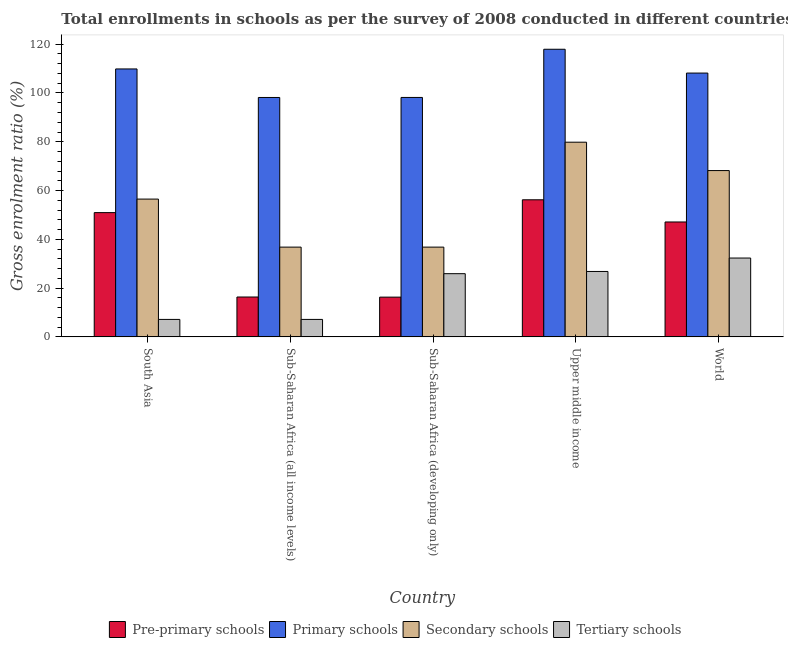Are the number of bars per tick equal to the number of legend labels?
Your answer should be very brief. Yes. How many bars are there on the 1st tick from the left?
Keep it short and to the point. 4. How many bars are there on the 3rd tick from the right?
Ensure brevity in your answer.  4. What is the label of the 5th group of bars from the left?
Ensure brevity in your answer.  World. What is the gross enrolment ratio in pre-primary schools in South Asia?
Your answer should be compact. 50.95. Across all countries, what is the maximum gross enrolment ratio in secondary schools?
Your answer should be very brief. 79.82. Across all countries, what is the minimum gross enrolment ratio in primary schools?
Your response must be concise. 98.16. In which country was the gross enrolment ratio in secondary schools maximum?
Offer a very short reply. Upper middle income. In which country was the gross enrolment ratio in primary schools minimum?
Your answer should be compact. Sub-Saharan Africa (all income levels). What is the total gross enrolment ratio in tertiary schools in the graph?
Offer a very short reply. 99.37. What is the difference between the gross enrolment ratio in secondary schools in Sub-Saharan Africa (developing only) and that in Upper middle income?
Give a very brief answer. -43.02. What is the difference between the gross enrolment ratio in tertiary schools in Upper middle income and the gross enrolment ratio in pre-primary schools in South Asia?
Give a very brief answer. -24.13. What is the average gross enrolment ratio in tertiary schools per country?
Give a very brief answer. 19.87. What is the difference between the gross enrolment ratio in primary schools and gross enrolment ratio in tertiary schools in Sub-Saharan Africa (developing only)?
Give a very brief answer. 72.26. In how many countries, is the gross enrolment ratio in pre-primary schools greater than 12 %?
Offer a very short reply. 5. What is the ratio of the gross enrolment ratio in tertiary schools in South Asia to that in World?
Keep it short and to the point. 0.22. Is the gross enrolment ratio in secondary schools in Sub-Saharan Africa (developing only) less than that in Upper middle income?
Your response must be concise. Yes. What is the difference between the highest and the second highest gross enrolment ratio in tertiary schools?
Provide a short and direct response. 5.5. What is the difference between the highest and the lowest gross enrolment ratio in primary schools?
Provide a succinct answer. 19.77. In how many countries, is the gross enrolment ratio in pre-primary schools greater than the average gross enrolment ratio in pre-primary schools taken over all countries?
Your answer should be very brief. 3. Is the sum of the gross enrolment ratio in tertiary schools in Sub-Saharan Africa (developing only) and World greater than the maximum gross enrolment ratio in primary schools across all countries?
Provide a short and direct response. No. Is it the case that in every country, the sum of the gross enrolment ratio in tertiary schools and gross enrolment ratio in primary schools is greater than the sum of gross enrolment ratio in secondary schools and gross enrolment ratio in pre-primary schools?
Offer a very short reply. Yes. What does the 3rd bar from the left in South Asia represents?
Provide a succinct answer. Secondary schools. What does the 3rd bar from the right in Sub-Saharan Africa (developing only) represents?
Offer a terse response. Primary schools. How many bars are there?
Provide a succinct answer. 20. Are the values on the major ticks of Y-axis written in scientific E-notation?
Offer a very short reply. No. Where does the legend appear in the graph?
Your answer should be very brief. Bottom center. How many legend labels are there?
Offer a terse response. 4. How are the legend labels stacked?
Offer a terse response. Horizontal. What is the title of the graph?
Offer a terse response. Total enrollments in schools as per the survey of 2008 conducted in different countries. Does "Other Minerals" appear as one of the legend labels in the graph?
Your response must be concise. No. What is the label or title of the Y-axis?
Keep it short and to the point. Gross enrolment ratio (%). What is the Gross enrolment ratio (%) in Pre-primary schools in South Asia?
Ensure brevity in your answer.  50.95. What is the Gross enrolment ratio (%) in Primary schools in South Asia?
Your answer should be very brief. 109.86. What is the Gross enrolment ratio (%) in Secondary schools in South Asia?
Your answer should be compact. 56.5. What is the Gross enrolment ratio (%) of Tertiary schools in South Asia?
Offer a terse response. 7.16. What is the Gross enrolment ratio (%) in Pre-primary schools in Sub-Saharan Africa (all income levels)?
Provide a short and direct response. 16.34. What is the Gross enrolment ratio (%) in Primary schools in Sub-Saharan Africa (all income levels)?
Make the answer very short. 98.16. What is the Gross enrolment ratio (%) in Secondary schools in Sub-Saharan Africa (all income levels)?
Keep it short and to the point. 36.8. What is the Gross enrolment ratio (%) in Tertiary schools in Sub-Saharan Africa (all income levels)?
Your answer should be very brief. 7.16. What is the Gross enrolment ratio (%) of Pre-primary schools in Sub-Saharan Africa (developing only)?
Your response must be concise. 16.3. What is the Gross enrolment ratio (%) of Primary schools in Sub-Saharan Africa (developing only)?
Provide a succinct answer. 98.17. What is the Gross enrolment ratio (%) in Secondary schools in Sub-Saharan Africa (developing only)?
Ensure brevity in your answer.  36.8. What is the Gross enrolment ratio (%) in Tertiary schools in Sub-Saharan Africa (developing only)?
Your response must be concise. 25.91. What is the Gross enrolment ratio (%) of Pre-primary schools in Upper middle income?
Provide a short and direct response. 56.21. What is the Gross enrolment ratio (%) of Primary schools in Upper middle income?
Make the answer very short. 117.93. What is the Gross enrolment ratio (%) in Secondary schools in Upper middle income?
Offer a very short reply. 79.82. What is the Gross enrolment ratio (%) in Tertiary schools in Upper middle income?
Keep it short and to the point. 26.82. What is the Gross enrolment ratio (%) in Pre-primary schools in World?
Offer a terse response. 47.11. What is the Gross enrolment ratio (%) in Primary schools in World?
Make the answer very short. 108.17. What is the Gross enrolment ratio (%) in Secondary schools in World?
Make the answer very short. 68.19. What is the Gross enrolment ratio (%) in Tertiary schools in World?
Your answer should be very brief. 32.32. Across all countries, what is the maximum Gross enrolment ratio (%) of Pre-primary schools?
Your answer should be compact. 56.21. Across all countries, what is the maximum Gross enrolment ratio (%) of Primary schools?
Your answer should be very brief. 117.93. Across all countries, what is the maximum Gross enrolment ratio (%) in Secondary schools?
Provide a short and direct response. 79.82. Across all countries, what is the maximum Gross enrolment ratio (%) in Tertiary schools?
Provide a short and direct response. 32.32. Across all countries, what is the minimum Gross enrolment ratio (%) in Pre-primary schools?
Provide a succinct answer. 16.3. Across all countries, what is the minimum Gross enrolment ratio (%) in Primary schools?
Your response must be concise. 98.16. Across all countries, what is the minimum Gross enrolment ratio (%) in Secondary schools?
Ensure brevity in your answer.  36.8. Across all countries, what is the minimum Gross enrolment ratio (%) in Tertiary schools?
Your answer should be compact. 7.16. What is the total Gross enrolment ratio (%) of Pre-primary schools in the graph?
Your answer should be very brief. 186.91. What is the total Gross enrolment ratio (%) of Primary schools in the graph?
Provide a succinct answer. 532.28. What is the total Gross enrolment ratio (%) of Secondary schools in the graph?
Give a very brief answer. 278.1. What is the total Gross enrolment ratio (%) of Tertiary schools in the graph?
Ensure brevity in your answer.  99.37. What is the difference between the Gross enrolment ratio (%) in Pre-primary schools in South Asia and that in Sub-Saharan Africa (all income levels)?
Your response must be concise. 34.6. What is the difference between the Gross enrolment ratio (%) in Primary schools in South Asia and that in Sub-Saharan Africa (all income levels)?
Provide a succinct answer. 11.7. What is the difference between the Gross enrolment ratio (%) in Secondary schools in South Asia and that in Sub-Saharan Africa (all income levels)?
Provide a succinct answer. 19.7. What is the difference between the Gross enrolment ratio (%) in Tertiary schools in South Asia and that in Sub-Saharan Africa (all income levels)?
Make the answer very short. -0. What is the difference between the Gross enrolment ratio (%) of Pre-primary schools in South Asia and that in Sub-Saharan Africa (developing only)?
Provide a short and direct response. 34.65. What is the difference between the Gross enrolment ratio (%) of Primary schools in South Asia and that in Sub-Saharan Africa (developing only)?
Offer a terse response. 11.69. What is the difference between the Gross enrolment ratio (%) of Secondary schools in South Asia and that in Sub-Saharan Africa (developing only)?
Give a very brief answer. 19.69. What is the difference between the Gross enrolment ratio (%) of Tertiary schools in South Asia and that in Sub-Saharan Africa (developing only)?
Give a very brief answer. -18.75. What is the difference between the Gross enrolment ratio (%) in Pre-primary schools in South Asia and that in Upper middle income?
Provide a succinct answer. -5.26. What is the difference between the Gross enrolment ratio (%) of Primary schools in South Asia and that in Upper middle income?
Your answer should be very brief. -8.07. What is the difference between the Gross enrolment ratio (%) of Secondary schools in South Asia and that in Upper middle income?
Make the answer very short. -23.32. What is the difference between the Gross enrolment ratio (%) in Tertiary schools in South Asia and that in Upper middle income?
Offer a very short reply. -19.66. What is the difference between the Gross enrolment ratio (%) of Pre-primary schools in South Asia and that in World?
Offer a very short reply. 3.83. What is the difference between the Gross enrolment ratio (%) in Primary schools in South Asia and that in World?
Make the answer very short. 1.69. What is the difference between the Gross enrolment ratio (%) of Secondary schools in South Asia and that in World?
Your answer should be very brief. -11.69. What is the difference between the Gross enrolment ratio (%) in Tertiary schools in South Asia and that in World?
Offer a very short reply. -25.16. What is the difference between the Gross enrolment ratio (%) in Pre-primary schools in Sub-Saharan Africa (all income levels) and that in Sub-Saharan Africa (developing only)?
Offer a very short reply. 0.05. What is the difference between the Gross enrolment ratio (%) of Primary schools in Sub-Saharan Africa (all income levels) and that in Sub-Saharan Africa (developing only)?
Provide a succinct answer. -0.01. What is the difference between the Gross enrolment ratio (%) of Secondary schools in Sub-Saharan Africa (all income levels) and that in Sub-Saharan Africa (developing only)?
Provide a short and direct response. -0. What is the difference between the Gross enrolment ratio (%) of Tertiary schools in Sub-Saharan Africa (all income levels) and that in Sub-Saharan Africa (developing only)?
Ensure brevity in your answer.  -18.75. What is the difference between the Gross enrolment ratio (%) in Pre-primary schools in Sub-Saharan Africa (all income levels) and that in Upper middle income?
Ensure brevity in your answer.  -39.86. What is the difference between the Gross enrolment ratio (%) in Primary schools in Sub-Saharan Africa (all income levels) and that in Upper middle income?
Your answer should be compact. -19.77. What is the difference between the Gross enrolment ratio (%) of Secondary schools in Sub-Saharan Africa (all income levels) and that in Upper middle income?
Offer a very short reply. -43.02. What is the difference between the Gross enrolment ratio (%) in Tertiary schools in Sub-Saharan Africa (all income levels) and that in Upper middle income?
Make the answer very short. -19.66. What is the difference between the Gross enrolment ratio (%) of Pre-primary schools in Sub-Saharan Africa (all income levels) and that in World?
Keep it short and to the point. -30.77. What is the difference between the Gross enrolment ratio (%) in Primary schools in Sub-Saharan Africa (all income levels) and that in World?
Offer a very short reply. -10.01. What is the difference between the Gross enrolment ratio (%) of Secondary schools in Sub-Saharan Africa (all income levels) and that in World?
Provide a succinct answer. -31.39. What is the difference between the Gross enrolment ratio (%) of Tertiary schools in Sub-Saharan Africa (all income levels) and that in World?
Provide a short and direct response. -25.16. What is the difference between the Gross enrolment ratio (%) in Pre-primary schools in Sub-Saharan Africa (developing only) and that in Upper middle income?
Your answer should be very brief. -39.91. What is the difference between the Gross enrolment ratio (%) of Primary schools in Sub-Saharan Africa (developing only) and that in Upper middle income?
Make the answer very short. -19.76. What is the difference between the Gross enrolment ratio (%) in Secondary schools in Sub-Saharan Africa (developing only) and that in Upper middle income?
Make the answer very short. -43.02. What is the difference between the Gross enrolment ratio (%) in Tertiary schools in Sub-Saharan Africa (developing only) and that in Upper middle income?
Ensure brevity in your answer.  -0.91. What is the difference between the Gross enrolment ratio (%) in Pre-primary schools in Sub-Saharan Africa (developing only) and that in World?
Your answer should be compact. -30.82. What is the difference between the Gross enrolment ratio (%) of Primary schools in Sub-Saharan Africa (developing only) and that in World?
Offer a very short reply. -10. What is the difference between the Gross enrolment ratio (%) in Secondary schools in Sub-Saharan Africa (developing only) and that in World?
Offer a terse response. -31.39. What is the difference between the Gross enrolment ratio (%) of Tertiary schools in Sub-Saharan Africa (developing only) and that in World?
Your answer should be compact. -6.41. What is the difference between the Gross enrolment ratio (%) of Pre-primary schools in Upper middle income and that in World?
Offer a very short reply. 9.1. What is the difference between the Gross enrolment ratio (%) in Primary schools in Upper middle income and that in World?
Make the answer very short. 9.76. What is the difference between the Gross enrolment ratio (%) of Secondary schools in Upper middle income and that in World?
Provide a short and direct response. 11.63. What is the difference between the Gross enrolment ratio (%) of Tertiary schools in Upper middle income and that in World?
Your answer should be compact. -5.5. What is the difference between the Gross enrolment ratio (%) of Pre-primary schools in South Asia and the Gross enrolment ratio (%) of Primary schools in Sub-Saharan Africa (all income levels)?
Your answer should be very brief. -47.21. What is the difference between the Gross enrolment ratio (%) of Pre-primary schools in South Asia and the Gross enrolment ratio (%) of Secondary schools in Sub-Saharan Africa (all income levels)?
Your response must be concise. 14.15. What is the difference between the Gross enrolment ratio (%) of Pre-primary schools in South Asia and the Gross enrolment ratio (%) of Tertiary schools in Sub-Saharan Africa (all income levels)?
Provide a succinct answer. 43.79. What is the difference between the Gross enrolment ratio (%) in Primary schools in South Asia and the Gross enrolment ratio (%) in Secondary schools in Sub-Saharan Africa (all income levels)?
Provide a short and direct response. 73.06. What is the difference between the Gross enrolment ratio (%) of Primary schools in South Asia and the Gross enrolment ratio (%) of Tertiary schools in Sub-Saharan Africa (all income levels)?
Give a very brief answer. 102.7. What is the difference between the Gross enrolment ratio (%) in Secondary schools in South Asia and the Gross enrolment ratio (%) in Tertiary schools in Sub-Saharan Africa (all income levels)?
Offer a very short reply. 49.33. What is the difference between the Gross enrolment ratio (%) in Pre-primary schools in South Asia and the Gross enrolment ratio (%) in Primary schools in Sub-Saharan Africa (developing only)?
Offer a very short reply. -47.22. What is the difference between the Gross enrolment ratio (%) of Pre-primary schools in South Asia and the Gross enrolment ratio (%) of Secondary schools in Sub-Saharan Africa (developing only)?
Provide a short and direct response. 14.14. What is the difference between the Gross enrolment ratio (%) of Pre-primary schools in South Asia and the Gross enrolment ratio (%) of Tertiary schools in Sub-Saharan Africa (developing only)?
Your response must be concise. 25.04. What is the difference between the Gross enrolment ratio (%) of Primary schools in South Asia and the Gross enrolment ratio (%) of Secondary schools in Sub-Saharan Africa (developing only)?
Provide a short and direct response. 73.06. What is the difference between the Gross enrolment ratio (%) of Primary schools in South Asia and the Gross enrolment ratio (%) of Tertiary schools in Sub-Saharan Africa (developing only)?
Provide a short and direct response. 83.95. What is the difference between the Gross enrolment ratio (%) of Secondary schools in South Asia and the Gross enrolment ratio (%) of Tertiary schools in Sub-Saharan Africa (developing only)?
Give a very brief answer. 30.58. What is the difference between the Gross enrolment ratio (%) in Pre-primary schools in South Asia and the Gross enrolment ratio (%) in Primary schools in Upper middle income?
Your answer should be very brief. -66.98. What is the difference between the Gross enrolment ratio (%) of Pre-primary schools in South Asia and the Gross enrolment ratio (%) of Secondary schools in Upper middle income?
Your response must be concise. -28.87. What is the difference between the Gross enrolment ratio (%) of Pre-primary schools in South Asia and the Gross enrolment ratio (%) of Tertiary schools in Upper middle income?
Offer a very short reply. 24.13. What is the difference between the Gross enrolment ratio (%) of Primary schools in South Asia and the Gross enrolment ratio (%) of Secondary schools in Upper middle income?
Offer a very short reply. 30.04. What is the difference between the Gross enrolment ratio (%) in Primary schools in South Asia and the Gross enrolment ratio (%) in Tertiary schools in Upper middle income?
Your answer should be very brief. 83.04. What is the difference between the Gross enrolment ratio (%) in Secondary schools in South Asia and the Gross enrolment ratio (%) in Tertiary schools in Upper middle income?
Provide a short and direct response. 29.67. What is the difference between the Gross enrolment ratio (%) of Pre-primary schools in South Asia and the Gross enrolment ratio (%) of Primary schools in World?
Give a very brief answer. -57.22. What is the difference between the Gross enrolment ratio (%) of Pre-primary schools in South Asia and the Gross enrolment ratio (%) of Secondary schools in World?
Keep it short and to the point. -17.24. What is the difference between the Gross enrolment ratio (%) of Pre-primary schools in South Asia and the Gross enrolment ratio (%) of Tertiary schools in World?
Provide a succinct answer. 18.63. What is the difference between the Gross enrolment ratio (%) in Primary schools in South Asia and the Gross enrolment ratio (%) in Secondary schools in World?
Ensure brevity in your answer.  41.67. What is the difference between the Gross enrolment ratio (%) of Primary schools in South Asia and the Gross enrolment ratio (%) of Tertiary schools in World?
Provide a short and direct response. 77.54. What is the difference between the Gross enrolment ratio (%) of Secondary schools in South Asia and the Gross enrolment ratio (%) of Tertiary schools in World?
Your answer should be compact. 24.17. What is the difference between the Gross enrolment ratio (%) of Pre-primary schools in Sub-Saharan Africa (all income levels) and the Gross enrolment ratio (%) of Primary schools in Sub-Saharan Africa (developing only)?
Make the answer very short. -81.82. What is the difference between the Gross enrolment ratio (%) of Pre-primary schools in Sub-Saharan Africa (all income levels) and the Gross enrolment ratio (%) of Secondary schools in Sub-Saharan Africa (developing only)?
Keep it short and to the point. -20.46. What is the difference between the Gross enrolment ratio (%) of Pre-primary schools in Sub-Saharan Africa (all income levels) and the Gross enrolment ratio (%) of Tertiary schools in Sub-Saharan Africa (developing only)?
Give a very brief answer. -9.57. What is the difference between the Gross enrolment ratio (%) of Primary schools in Sub-Saharan Africa (all income levels) and the Gross enrolment ratio (%) of Secondary schools in Sub-Saharan Africa (developing only)?
Provide a short and direct response. 61.36. What is the difference between the Gross enrolment ratio (%) of Primary schools in Sub-Saharan Africa (all income levels) and the Gross enrolment ratio (%) of Tertiary schools in Sub-Saharan Africa (developing only)?
Provide a short and direct response. 72.25. What is the difference between the Gross enrolment ratio (%) in Secondary schools in Sub-Saharan Africa (all income levels) and the Gross enrolment ratio (%) in Tertiary schools in Sub-Saharan Africa (developing only)?
Your response must be concise. 10.89. What is the difference between the Gross enrolment ratio (%) of Pre-primary schools in Sub-Saharan Africa (all income levels) and the Gross enrolment ratio (%) of Primary schools in Upper middle income?
Your response must be concise. -101.59. What is the difference between the Gross enrolment ratio (%) of Pre-primary schools in Sub-Saharan Africa (all income levels) and the Gross enrolment ratio (%) of Secondary schools in Upper middle income?
Provide a short and direct response. -63.48. What is the difference between the Gross enrolment ratio (%) in Pre-primary schools in Sub-Saharan Africa (all income levels) and the Gross enrolment ratio (%) in Tertiary schools in Upper middle income?
Keep it short and to the point. -10.48. What is the difference between the Gross enrolment ratio (%) in Primary schools in Sub-Saharan Africa (all income levels) and the Gross enrolment ratio (%) in Secondary schools in Upper middle income?
Your answer should be compact. 18.34. What is the difference between the Gross enrolment ratio (%) in Primary schools in Sub-Saharan Africa (all income levels) and the Gross enrolment ratio (%) in Tertiary schools in Upper middle income?
Give a very brief answer. 71.34. What is the difference between the Gross enrolment ratio (%) of Secondary schools in Sub-Saharan Africa (all income levels) and the Gross enrolment ratio (%) of Tertiary schools in Upper middle income?
Your response must be concise. 9.98. What is the difference between the Gross enrolment ratio (%) of Pre-primary schools in Sub-Saharan Africa (all income levels) and the Gross enrolment ratio (%) of Primary schools in World?
Give a very brief answer. -91.82. What is the difference between the Gross enrolment ratio (%) in Pre-primary schools in Sub-Saharan Africa (all income levels) and the Gross enrolment ratio (%) in Secondary schools in World?
Make the answer very short. -51.85. What is the difference between the Gross enrolment ratio (%) in Pre-primary schools in Sub-Saharan Africa (all income levels) and the Gross enrolment ratio (%) in Tertiary schools in World?
Offer a terse response. -15.98. What is the difference between the Gross enrolment ratio (%) in Primary schools in Sub-Saharan Africa (all income levels) and the Gross enrolment ratio (%) in Secondary schools in World?
Make the answer very short. 29.97. What is the difference between the Gross enrolment ratio (%) of Primary schools in Sub-Saharan Africa (all income levels) and the Gross enrolment ratio (%) of Tertiary schools in World?
Provide a succinct answer. 65.84. What is the difference between the Gross enrolment ratio (%) in Secondary schools in Sub-Saharan Africa (all income levels) and the Gross enrolment ratio (%) in Tertiary schools in World?
Provide a short and direct response. 4.48. What is the difference between the Gross enrolment ratio (%) of Pre-primary schools in Sub-Saharan Africa (developing only) and the Gross enrolment ratio (%) of Primary schools in Upper middle income?
Provide a short and direct response. -101.63. What is the difference between the Gross enrolment ratio (%) of Pre-primary schools in Sub-Saharan Africa (developing only) and the Gross enrolment ratio (%) of Secondary schools in Upper middle income?
Offer a terse response. -63.52. What is the difference between the Gross enrolment ratio (%) of Pre-primary schools in Sub-Saharan Africa (developing only) and the Gross enrolment ratio (%) of Tertiary schools in Upper middle income?
Offer a terse response. -10.53. What is the difference between the Gross enrolment ratio (%) in Primary schools in Sub-Saharan Africa (developing only) and the Gross enrolment ratio (%) in Secondary schools in Upper middle income?
Offer a terse response. 18.35. What is the difference between the Gross enrolment ratio (%) in Primary schools in Sub-Saharan Africa (developing only) and the Gross enrolment ratio (%) in Tertiary schools in Upper middle income?
Give a very brief answer. 71.35. What is the difference between the Gross enrolment ratio (%) in Secondary schools in Sub-Saharan Africa (developing only) and the Gross enrolment ratio (%) in Tertiary schools in Upper middle income?
Your answer should be compact. 9.98. What is the difference between the Gross enrolment ratio (%) in Pre-primary schools in Sub-Saharan Africa (developing only) and the Gross enrolment ratio (%) in Primary schools in World?
Provide a succinct answer. -91.87. What is the difference between the Gross enrolment ratio (%) of Pre-primary schools in Sub-Saharan Africa (developing only) and the Gross enrolment ratio (%) of Secondary schools in World?
Make the answer very short. -51.89. What is the difference between the Gross enrolment ratio (%) in Pre-primary schools in Sub-Saharan Africa (developing only) and the Gross enrolment ratio (%) in Tertiary schools in World?
Provide a short and direct response. -16.03. What is the difference between the Gross enrolment ratio (%) of Primary schools in Sub-Saharan Africa (developing only) and the Gross enrolment ratio (%) of Secondary schools in World?
Make the answer very short. 29.98. What is the difference between the Gross enrolment ratio (%) in Primary schools in Sub-Saharan Africa (developing only) and the Gross enrolment ratio (%) in Tertiary schools in World?
Give a very brief answer. 65.85. What is the difference between the Gross enrolment ratio (%) in Secondary schools in Sub-Saharan Africa (developing only) and the Gross enrolment ratio (%) in Tertiary schools in World?
Provide a short and direct response. 4.48. What is the difference between the Gross enrolment ratio (%) in Pre-primary schools in Upper middle income and the Gross enrolment ratio (%) in Primary schools in World?
Offer a terse response. -51.96. What is the difference between the Gross enrolment ratio (%) of Pre-primary schools in Upper middle income and the Gross enrolment ratio (%) of Secondary schools in World?
Provide a short and direct response. -11.98. What is the difference between the Gross enrolment ratio (%) of Pre-primary schools in Upper middle income and the Gross enrolment ratio (%) of Tertiary schools in World?
Ensure brevity in your answer.  23.89. What is the difference between the Gross enrolment ratio (%) in Primary schools in Upper middle income and the Gross enrolment ratio (%) in Secondary schools in World?
Offer a very short reply. 49.74. What is the difference between the Gross enrolment ratio (%) in Primary schools in Upper middle income and the Gross enrolment ratio (%) in Tertiary schools in World?
Your answer should be very brief. 85.61. What is the difference between the Gross enrolment ratio (%) of Secondary schools in Upper middle income and the Gross enrolment ratio (%) of Tertiary schools in World?
Ensure brevity in your answer.  47.5. What is the average Gross enrolment ratio (%) of Pre-primary schools per country?
Your response must be concise. 37.38. What is the average Gross enrolment ratio (%) in Primary schools per country?
Give a very brief answer. 106.46. What is the average Gross enrolment ratio (%) in Secondary schools per country?
Offer a terse response. 55.62. What is the average Gross enrolment ratio (%) of Tertiary schools per country?
Your answer should be very brief. 19.87. What is the difference between the Gross enrolment ratio (%) of Pre-primary schools and Gross enrolment ratio (%) of Primary schools in South Asia?
Offer a very short reply. -58.91. What is the difference between the Gross enrolment ratio (%) of Pre-primary schools and Gross enrolment ratio (%) of Secondary schools in South Asia?
Your answer should be very brief. -5.55. What is the difference between the Gross enrolment ratio (%) in Pre-primary schools and Gross enrolment ratio (%) in Tertiary schools in South Asia?
Keep it short and to the point. 43.79. What is the difference between the Gross enrolment ratio (%) in Primary schools and Gross enrolment ratio (%) in Secondary schools in South Asia?
Your answer should be very brief. 53.36. What is the difference between the Gross enrolment ratio (%) of Primary schools and Gross enrolment ratio (%) of Tertiary schools in South Asia?
Give a very brief answer. 102.7. What is the difference between the Gross enrolment ratio (%) of Secondary schools and Gross enrolment ratio (%) of Tertiary schools in South Asia?
Offer a terse response. 49.34. What is the difference between the Gross enrolment ratio (%) of Pre-primary schools and Gross enrolment ratio (%) of Primary schools in Sub-Saharan Africa (all income levels)?
Your response must be concise. -81.82. What is the difference between the Gross enrolment ratio (%) in Pre-primary schools and Gross enrolment ratio (%) in Secondary schools in Sub-Saharan Africa (all income levels)?
Keep it short and to the point. -20.46. What is the difference between the Gross enrolment ratio (%) in Pre-primary schools and Gross enrolment ratio (%) in Tertiary schools in Sub-Saharan Africa (all income levels)?
Offer a terse response. 9.18. What is the difference between the Gross enrolment ratio (%) in Primary schools and Gross enrolment ratio (%) in Secondary schools in Sub-Saharan Africa (all income levels)?
Offer a terse response. 61.36. What is the difference between the Gross enrolment ratio (%) of Primary schools and Gross enrolment ratio (%) of Tertiary schools in Sub-Saharan Africa (all income levels)?
Give a very brief answer. 91. What is the difference between the Gross enrolment ratio (%) of Secondary schools and Gross enrolment ratio (%) of Tertiary schools in Sub-Saharan Africa (all income levels)?
Make the answer very short. 29.64. What is the difference between the Gross enrolment ratio (%) in Pre-primary schools and Gross enrolment ratio (%) in Primary schools in Sub-Saharan Africa (developing only)?
Make the answer very short. -81.87. What is the difference between the Gross enrolment ratio (%) of Pre-primary schools and Gross enrolment ratio (%) of Secondary schools in Sub-Saharan Africa (developing only)?
Keep it short and to the point. -20.51. What is the difference between the Gross enrolment ratio (%) of Pre-primary schools and Gross enrolment ratio (%) of Tertiary schools in Sub-Saharan Africa (developing only)?
Your response must be concise. -9.62. What is the difference between the Gross enrolment ratio (%) of Primary schools and Gross enrolment ratio (%) of Secondary schools in Sub-Saharan Africa (developing only)?
Ensure brevity in your answer.  61.37. What is the difference between the Gross enrolment ratio (%) in Primary schools and Gross enrolment ratio (%) in Tertiary schools in Sub-Saharan Africa (developing only)?
Offer a terse response. 72.26. What is the difference between the Gross enrolment ratio (%) of Secondary schools and Gross enrolment ratio (%) of Tertiary schools in Sub-Saharan Africa (developing only)?
Keep it short and to the point. 10.89. What is the difference between the Gross enrolment ratio (%) of Pre-primary schools and Gross enrolment ratio (%) of Primary schools in Upper middle income?
Offer a very short reply. -61.72. What is the difference between the Gross enrolment ratio (%) of Pre-primary schools and Gross enrolment ratio (%) of Secondary schools in Upper middle income?
Ensure brevity in your answer.  -23.61. What is the difference between the Gross enrolment ratio (%) in Pre-primary schools and Gross enrolment ratio (%) in Tertiary schools in Upper middle income?
Provide a short and direct response. 29.39. What is the difference between the Gross enrolment ratio (%) of Primary schools and Gross enrolment ratio (%) of Secondary schools in Upper middle income?
Ensure brevity in your answer.  38.11. What is the difference between the Gross enrolment ratio (%) in Primary schools and Gross enrolment ratio (%) in Tertiary schools in Upper middle income?
Offer a terse response. 91.11. What is the difference between the Gross enrolment ratio (%) in Secondary schools and Gross enrolment ratio (%) in Tertiary schools in Upper middle income?
Ensure brevity in your answer.  53. What is the difference between the Gross enrolment ratio (%) of Pre-primary schools and Gross enrolment ratio (%) of Primary schools in World?
Provide a short and direct response. -61.05. What is the difference between the Gross enrolment ratio (%) of Pre-primary schools and Gross enrolment ratio (%) of Secondary schools in World?
Your answer should be compact. -21.08. What is the difference between the Gross enrolment ratio (%) in Pre-primary schools and Gross enrolment ratio (%) in Tertiary schools in World?
Provide a short and direct response. 14.79. What is the difference between the Gross enrolment ratio (%) in Primary schools and Gross enrolment ratio (%) in Secondary schools in World?
Provide a short and direct response. 39.98. What is the difference between the Gross enrolment ratio (%) in Primary schools and Gross enrolment ratio (%) in Tertiary schools in World?
Keep it short and to the point. 75.85. What is the difference between the Gross enrolment ratio (%) in Secondary schools and Gross enrolment ratio (%) in Tertiary schools in World?
Your answer should be very brief. 35.87. What is the ratio of the Gross enrolment ratio (%) of Pre-primary schools in South Asia to that in Sub-Saharan Africa (all income levels)?
Offer a very short reply. 3.12. What is the ratio of the Gross enrolment ratio (%) in Primary schools in South Asia to that in Sub-Saharan Africa (all income levels)?
Keep it short and to the point. 1.12. What is the ratio of the Gross enrolment ratio (%) of Secondary schools in South Asia to that in Sub-Saharan Africa (all income levels)?
Your answer should be very brief. 1.54. What is the ratio of the Gross enrolment ratio (%) of Tertiary schools in South Asia to that in Sub-Saharan Africa (all income levels)?
Provide a short and direct response. 1. What is the ratio of the Gross enrolment ratio (%) in Pre-primary schools in South Asia to that in Sub-Saharan Africa (developing only)?
Ensure brevity in your answer.  3.13. What is the ratio of the Gross enrolment ratio (%) of Primary schools in South Asia to that in Sub-Saharan Africa (developing only)?
Offer a terse response. 1.12. What is the ratio of the Gross enrolment ratio (%) in Secondary schools in South Asia to that in Sub-Saharan Africa (developing only)?
Make the answer very short. 1.54. What is the ratio of the Gross enrolment ratio (%) of Tertiary schools in South Asia to that in Sub-Saharan Africa (developing only)?
Provide a succinct answer. 0.28. What is the ratio of the Gross enrolment ratio (%) of Pre-primary schools in South Asia to that in Upper middle income?
Offer a very short reply. 0.91. What is the ratio of the Gross enrolment ratio (%) of Primary schools in South Asia to that in Upper middle income?
Provide a succinct answer. 0.93. What is the ratio of the Gross enrolment ratio (%) in Secondary schools in South Asia to that in Upper middle income?
Your response must be concise. 0.71. What is the ratio of the Gross enrolment ratio (%) in Tertiary schools in South Asia to that in Upper middle income?
Provide a short and direct response. 0.27. What is the ratio of the Gross enrolment ratio (%) in Pre-primary schools in South Asia to that in World?
Provide a succinct answer. 1.08. What is the ratio of the Gross enrolment ratio (%) of Primary schools in South Asia to that in World?
Provide a succinct answer. 1.02. What is the ratio of the Gross enrolment ratio (%) in Secondary schools in South Asia to that in World?
Ensure brevity in your answer.  0.83. What is the ratio of the Gross enrolment ratio (%) of Tertiary schools in South Asia to that in World?
Keep it short and to the point. 0.22. What is the ratio of the Gross enrolment ratio (%) of Pre-primary schools in Sub-Saharan Africa (all income levels) to that in Sub-Saharan Africa (developing only)?
Offer a terse response. 1. What is the ratio of the Gross enrolment ratio (%) of Secondary schools in Sub-Saharan Africa (all income levels) to that in Sub-Saharan Africa (developing only)?
Your answer should be very brief. 1. What is the ratio of the Gross enrolment ratio (%) in Tertiary schools in Sub-Saharan Africa (all income levels) to that in Sub-Saharan Africa (developing only)?
Your answer should be very brief. 0.28. What is the ratio of the Gross enrolment ratio (%) in Pre-primary schools in Sub-Saharan Africa (all income levels) to that in Upper middle income?
Your answer should be very brief. 0.29. What is the ratio of the Gross enrolment ratio (%) of Primary schools in Sub-Saharan Africa (all income levels) to that in Upper middle income?
Keep it short and to the point. 0.83. What is the ratio of the Gross enrolment ratio (%) in Secondary schools in Sub-Saharan Africa (all income levels) to that in Upper middle income?
Offer a terse response. 0.46. What is the ratio of the Gross enrolment ratio (%) of Tertiary schools in Sub-Saharan Africa (all income levels) to that in Upper middle income?
Keep it short and to the point. 0.27. What is the ratio of the Gross enrolment ratio (%) of Pre-primary schools in Sub-Saharan Africa (all income levels) to that in World?
Make the answer very short. 0.35. What is the ratio of the Gross enrolment ratio (%) of Primary schools in Sub-Saharan Africa (all income levels) to that in World?
Your response must be concise. 0.91. What is the ratio of the Gross enrolment ratio (%) in Secondary schools in Sub-Saharan Africa (all income levels) to that in World?
Provide a succinct answer. 0.54. What is the ratio of the Gross enrolment ratio (%) of Tertiary schools in Sub-Saharan Africa (all income levels) to that in World?
Give a very brief answer. 0.22. What is the ratio of the Gross enrolment ratio (%) of Pre-primary schools in Sub-Saharan Africa (developing only) to that in Upper middle income?
Provide a short and direct response. 0.29. What is the ratio of the Gross enrolment ratio (%) in Primary schools in Sub-Saharan Africa (developing only) to that in Upper middle income?
Your answer should be very brief. 0.83. What is the ratio of the Gross enrolment ratio (%) of Secondary schools in Sub-Saharan Africa (developing only) to that in Upper middle income?
Provide a short and direct response. 0.46. What is the ratio of the Gross enrolment ratio (%) in Tertiary schools in Sub-Saharan Africa (developing only) to that in Upper middle income?
Make the answer very short. 0.97. What is the ratio of the Gross enrolment ratio (%) in Pre-primary schools in Sub-Saharan Africa (developing only) to that in World?
Your answer should be very brief. 0.35. What is the ratio of the Gross enrolment ratio (%) of Primary schools in Sub-Saharan Africa (developing only) to that in World?
Keep it short and to the point. 0.91. What is the ratio of the Gross enrolment ratio (%) in Secondary schools in Sub-Saharan Africa (developing only) to that in World?
Your answer should be compact. 0.54. What is the ratio of the Gross enrolment ratio (%) in Tertiary schools in Sub-Saharan Africa (developing only) to that in World?
Make the answer very short. 0.8. What is the ratio of the Gross enrolment ratio (%) of Pre-primary schools in Upper middle income to that in World?
Offer a very short reply. 1.19. What is the ratio of the Gross enrolment ratio (%) in Primary schools in Upper middle income to that in World?
Make the answer very short. 1.09. What is the ratio of the Gross enrolment ratio (%) of Secondary schools in Upper middle income to that in World?
Offer a terse response. 1.17. What is the ratio of the Gross enrolment ratio (%) of Tertiary schools in Upper middle income to that in World?
Make the answer very short. 0.83. What is the difference between the highest and the second highest Gross enrolment ratio (%) of Pre-primary schools?
Offer a terse response. 5.26. What is the difference between the highest and the second highest Gross enrolment ratio (%) in Primary schools?
Keep it short and to the point. 8.07. What is the difference between the highest and the second highest Gross enrolment ratio (%) in Secondary schools?
Offer a very short reply. 11.63. What is the difference between the highest and the second highest Gross enrolment ratio (%) in Tertiary schools?
Provide a succinct answer. 5.5. What is the difference between the highest and the lowest Gross enrolment ratio (%) in Pre-primary schools?
Provide a short and direct response. 39.91. What is the difference between the highest and the lowest Gross enrolment ratio (%) of Primary schools?
Keep it short and to the point. 19.77. What is the difference between the highest and the lowest Gross enrolment ratio (%) of Secondary schools?
Your response must be concise. 43.02. What is the difference between the highest and the lowest Gross enrolment ratio (%) of Tertiary schools?
Offer a very short reply. 25.16. 